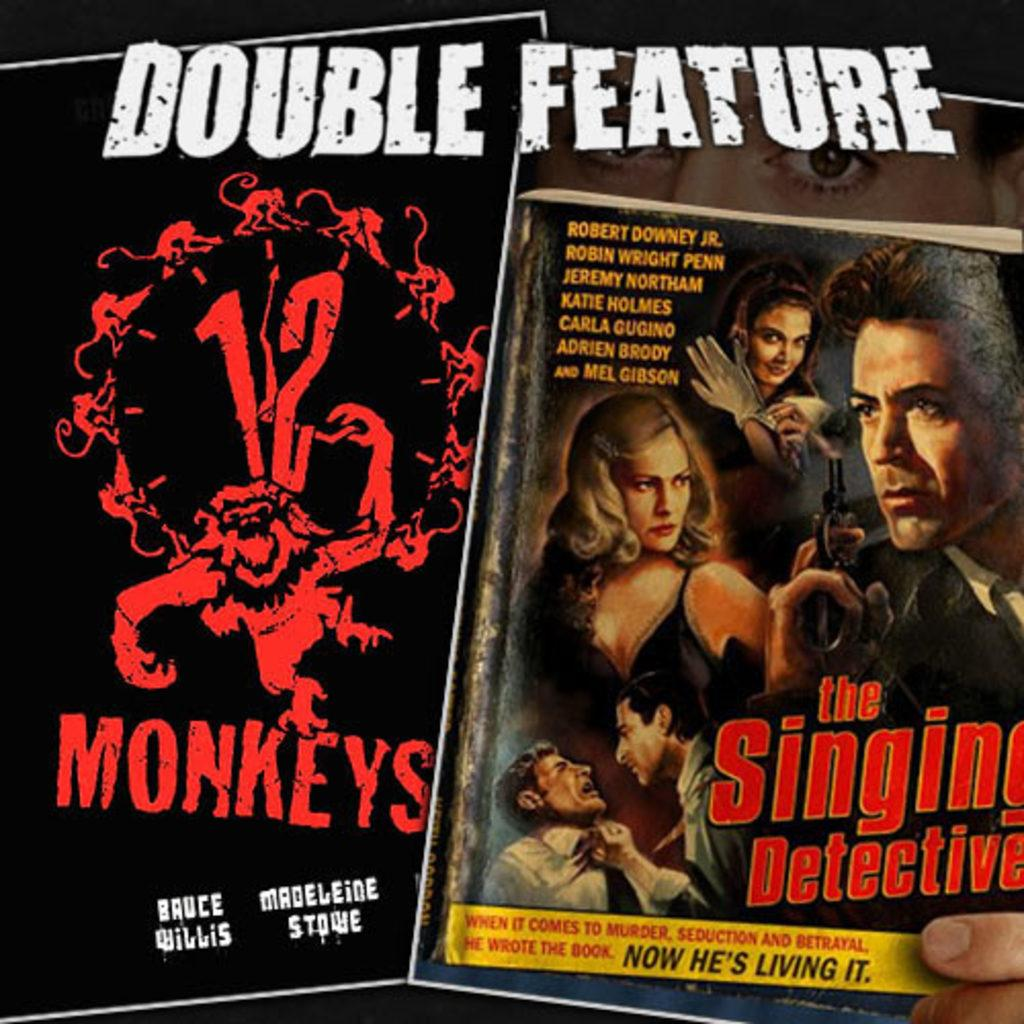<image>
Offer a succinct explanation of the picture presented. An advertisement for the movies twelve monkeys and the singing detective with the text double feature on the top. 